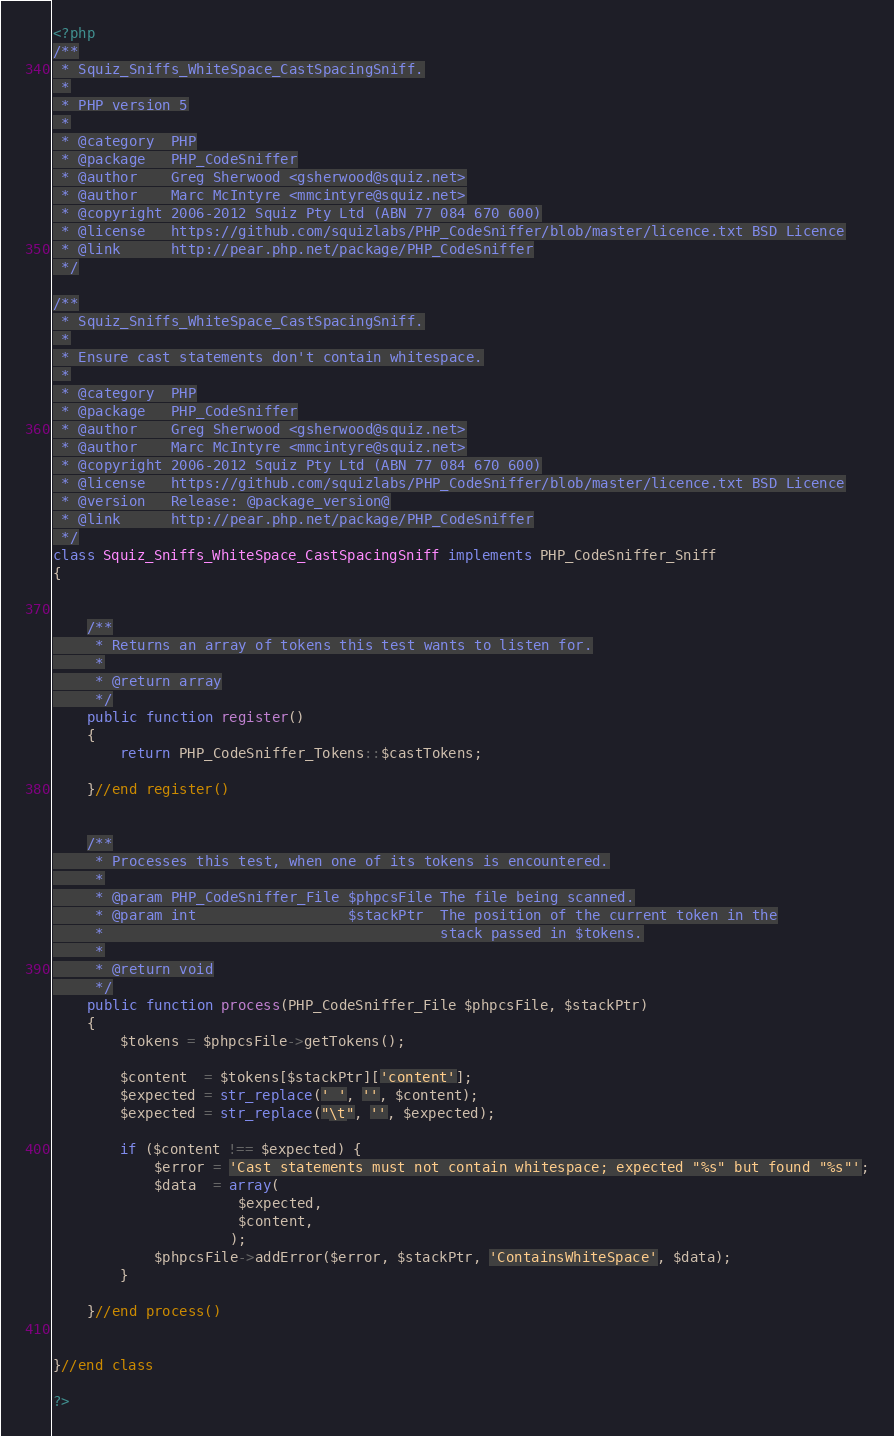<code> <loc_0><loc_0><loc_500><loc_500><_PHP_><?php
/**
 * Squiz_Sniffs_WhiteSpace_CastSpacingSniff.
 *
 * PHP version 5
 *
 * @category  PHP
 * @package   PHP_CodeSniffer
 * @author    Greg Sherwood <gsherwood@squiz.net>
 * @author    Marc McIntyre <mmcintyre@squiz.net>
 * @copyright 2006-2012 Squiz Pty Ltd (ABN 77 084 670 600)
 * @license   https://github.com/squizlabs/PHP_CodeSniffer/blob/master/licence.txt BSD Licence
 * @link      http://pear.php.net/package/PHP_CodeSniffer
 */

/**
 * Squiz_Sniffs_WhiteSpace_CastSpacingSniff.
 *
 * Ensure cast statements don't contain whitespace.
 *
 * @category  PHP
 * @package   PHP_CodeSniffer
 * @author    Greg Sherwood <gsherwood@squiz.net>
 * @author    Marc McIntyre <mmcintyre@squiz.net>
 * @copyright 2006-2012 Squiz Pty Ltd (ABN 77 084 670 600)
 * @license   https://github.com/squizlabs/PHP_CodeSniffer/blob/master/licence.txt BSD Licence
 * @version   Release: @package_version@
 * @link      http://pear.php.net/package/PHP_CodeSniffer
 */
class Squiz_Sniffs_WhiteSpace_CastSpacingSniff implements PHP_CodeSniffer_Sniff
{


    /**
     * Returns an array of tokens this test wants to listen for.
     *
     * @return array
     */
    public function register()
    {
        return PHP_CodeSniffer_Tokens::$castTokens;

    }//end register()


    /**
     * Processes this test, when one of its tokens is encountered.
     *
     * @param PHP_CodeSniffer_File $phpcsFile The file being scanned.
     * @param int                  $stackPtr  The position of the current token in the
     *                                        stack passed in $tokens.
     *
     * @return void
     */
    public function process(PHP_CodeSniffer_File $phpcsFile, $stackPtr)
    {
        $tokens = $phpcsFile->getTokens();

        $content  = $tokens[$stackPtr]['content'];
        $expected = str_replace(' ', '', $content);
        $expected = str_replace("\t", '', $expected);

        if ($content !== $expected) {
            $error = 'Cast statements must not contain whitespace; expected "%s" but found "%s"';
            $data  = array(
                      $expected,
                      $content,
                     );
            $phpcsFile->addError($error, $stackPtr, 'ContainsWhiteSpace', $data);
        }

    }//end process()


}//end class

?>
</code> 